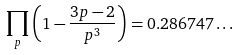Convert formula to latex. <formula><loc_0><loc_0><loc_500><loc_500>\prod _ { p } \left ( 1 - { \frac { 3 p - 2 } { p ^ { 3 } } } \right ) = 0 . 2 8 6 7 4 7 \dots</formula> 